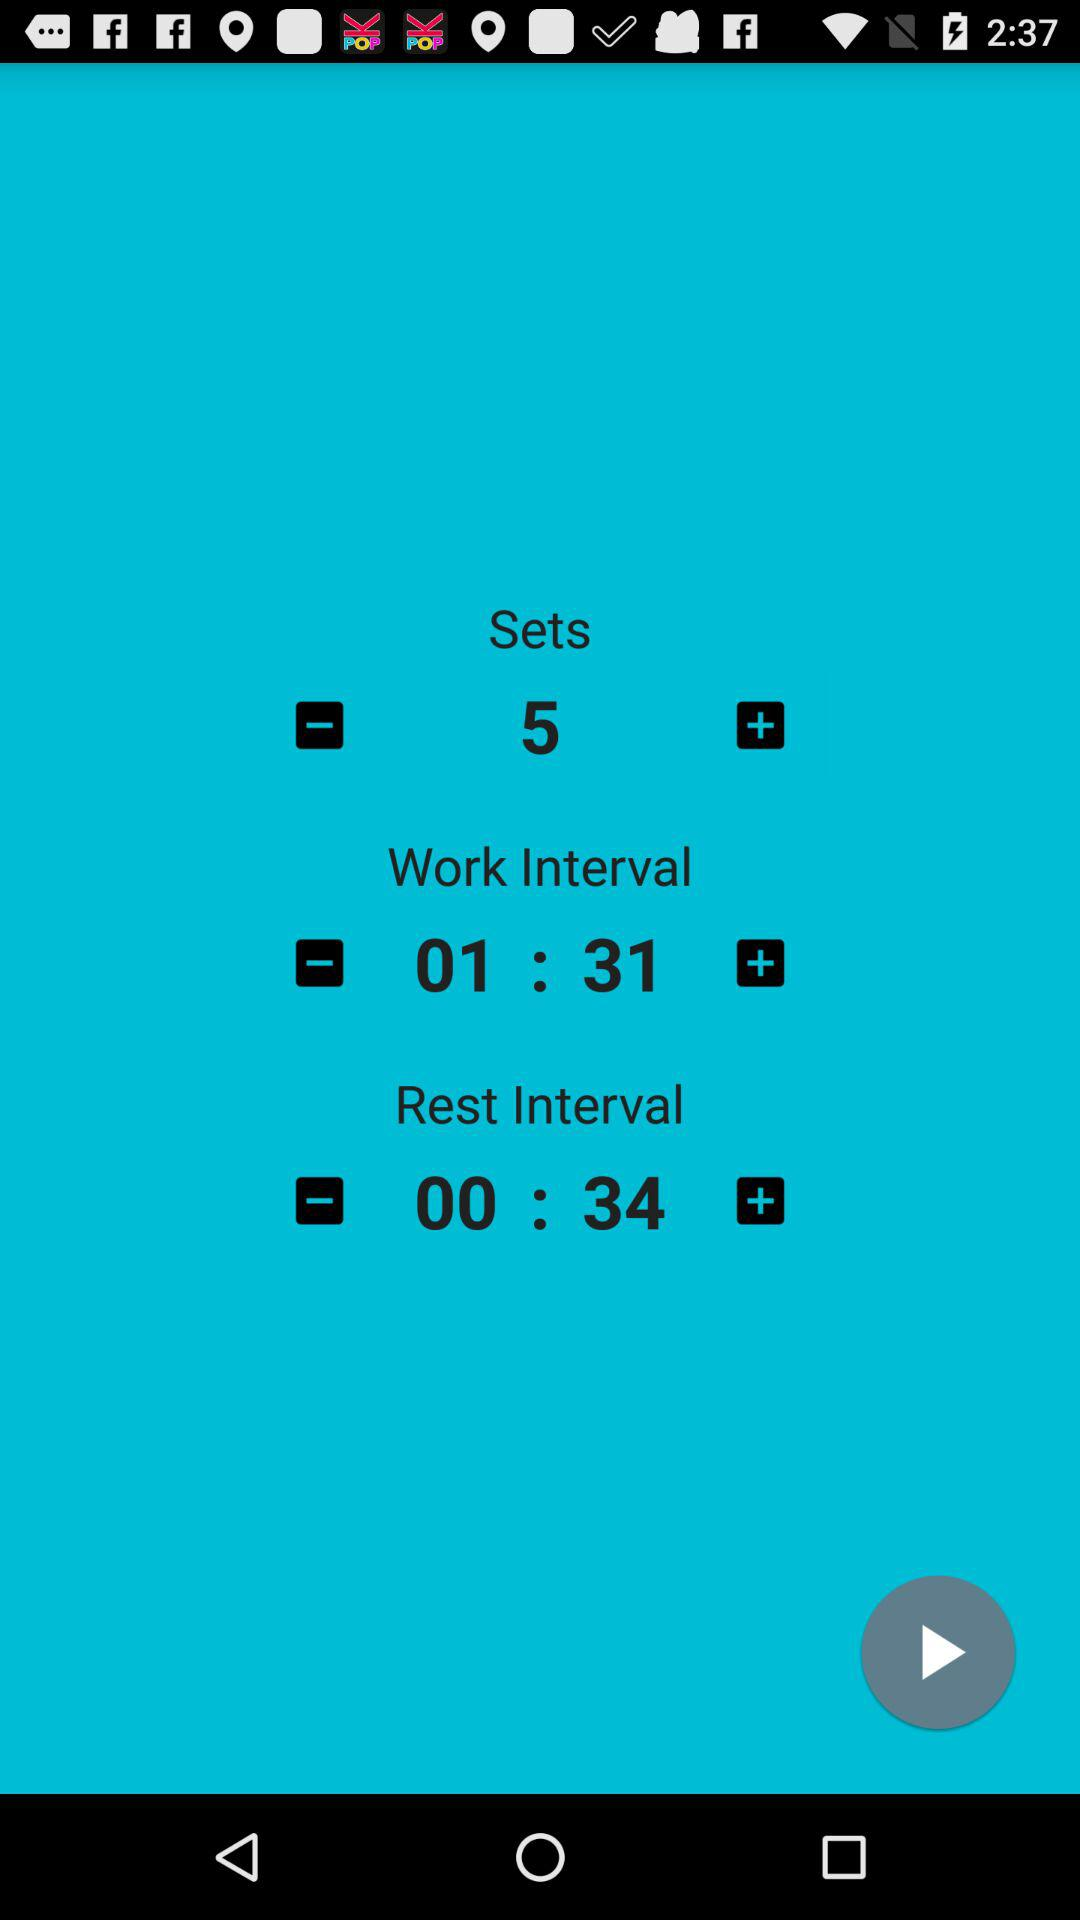How many sets are there?
Answer the question using a single word or phrase. 5 